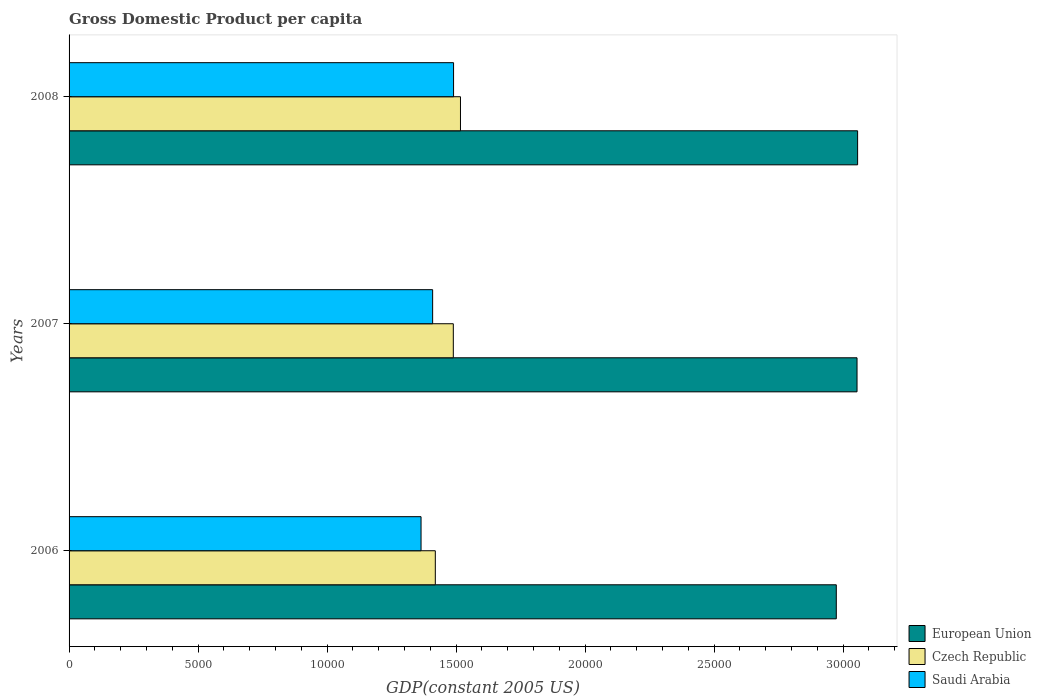How many groups of bars are there?
Your answer should be compact. 3. Are the number of bars per tick equal to the number of legend labels?
Your response must be concise. Yes. How many bars are there on the 1st tick from the bottom?
Offer a terse response. 3. What is the label of the 1st group of bars from the top?
Give a very brief answer. 2008. In how many cases, is the number of bars for a given year not equal to the number of legend labels?
Offer a very short reply. 0. What is the GDP per capita in Saudi Arabia in 2008?
Your response must be concise. 1.49e+04. Across all years, what is the maximum GDP per capita in Czech Republic?
Your response must be concise. 1.52e+04. Across all years, what is the minimum GDP per capita in European Union?
Offer a terse response. 2.97e+04. In which year was the GDP per capita in European Union maximum?
Keep it short and to the point. 2008. What is the total GDP per capita in European Union in the graph?
Provide a short and direct response. 9.08e+04. What is the difference between the GDP per capita in Czech Republic in 2006 and that in 2007?
Your response must be concise. -697.72. What is the difference between the GDP per capita in Czech Republic in 2008 and the GDP per capita in European Union in 2007?
Your answer should be very brief. -1.54e+04. What is the average GDP per capita in Czech Republic per year?
Make the answer very short. 1.48e+04. In the year 2008, what is the difference between the GDP per capita in European Union and GDP per capita in Saudi Arabia?
Provide a short and direct response. 1.57e+04. In how many years, is the GDP per capita in Saudi Arabia greater than 15000 US$?
Your answer should be compact. 0. What is the ratio of the GDP per capita in Czech Republic in 2006 to that in 2008?
Make the answer very short. 0.94. Is the difference between the GDP per capita in European Union in 2006 and 2007 greater than the difference between the GDP per capita in Saudi Arabia in 2006 and 2007?
Your answer should be compact. No. What is the difference between the highest and the second highest GDP per capita in Saudi Arabia?
Offer a very short reply. 810.83. What is the difference between the highest and the lowest GDP per capita in Saudi Arabia?
Ensure brevity in your answer.  1260.47. Is the sum of the GDP per capita in European Union in 2007 and 2008 greater than the maximum GDP per capita in Czech Republic across all years?
Your response must be concise. Yes. What does the 3rd bar from the top in 2006 represents?
Give a very brief answer. European Union. What does the 2nd bar from the bottom in 2006 represents?
Provide a succinct answer. Czech Republic. Is it the case that in every year, the sum of the GDP per capita in Czech Republic and GDP per capita in Saudi Arabia is greater than the GDP per capita in European Union?
Keep it short and to the point. No. How many years are there in the graph?
Provide a short and direct response. 3. What is the title of the graph?
Your answer should be very brief. Gross Domestic Product per capita. What is the label or title of the X-axis?
Make the answer very short. GDP(constant 2005 US). What is the GDP(constant 2005 US) of European Union in 2006?
Provide a short and direct response. 2.97e+04. What is the GDP(constant 2005 US) of Czech Republic in 2006?
Offer a very short reply. 1.42e+04. What is the GDP(constant 2005 US) of Saudi Arabia in 2006?
Make the answer very short. 1.36e+04. What is the GDP(constant 2005 US) of European Union in 2007?
Make the answer very short. 3.05e+04. What is the GDP(constant 2005 US) in Czech Republic in 2007?
Ensure brevity in your answer.  1.49e+04. What is the GDP(constant 2005 US) of Saudi Arabia in 2007?
Make the answer very short. 1.41e+04. What is the GDP(constant 2005 US) of European Union in 2008?
Give a very brief answer. 3.06e+04. What is the GDP(constant 2005 US) in Czech Republic in 2008?
Your answer should be very brief. 1.52e+04. What is the GDP(constant 2005 US) of Saudi Arabia in 2008?
Provide a succinct answer. 1.49e+04. Across all years, what is the maximum GDP(constant 2005 US) of European Union?
Ensure brevity in your answer.  3.06e+04. Across all years, what is the maximum GDP(constant 2005 US) in Czech Republic?
Offer a terse response. 1.52e+04. Across all years, what is the maximum GDP(constant 2005 US) in Saudi Arabia?
Give a very brief answer. 1.49e+04. Across all years, what is the minimum GDP(constant 2005 US) of European Union?
Provide a succinct answer. 2.97e+04. Across all years, what is the minimum GDP(constant 2005 US) of Czech Republic?
Offer a very short reply. 1.42e+04. Across all years, what is the minimum GDP(constant 2005 US) of Saudi Arabia?
Give a very brief answer. 1.36e+04. What is the total GDP(constant 2005 US) in European Union in the graph?
Provide a succinct answer. 9.08e+04. What is the total GDP(constant 2005 US) in Czech Republic in the graph?
Ensure brevity in your answer.  4.43e+04. What is the total GDP(constant 2005 US) in Saudi Arabia in the graph?
Provide a succinct answer. 4.26e+04. What is the difference between the GDP(constant 2005 US) in European Union in 2006 and that in 2007?
Keep it short and to the point. -803.51. What is the difference between the GDP(constant 2005 US) of Czech Republic in 2006 and that in 2007?
Offer a terse response. -697.72. What is the difference between the GDP(constant 2005 US) in Saudi Arabia in 2006 and that in 2007?
Give a very brief answer. -449.64. What is the difference between the GDP(constant 2005 US) in European Union in 2006 and that in 2008?
Your answer should be compact. -825.92. What is the difference between the GDP(constant 2005 US) of Czech Republic in 2006 and that in 2008?
Offer a terse response. -975.11. What is the difference between the GDP(constant 2005 US) of Saudi Arabia in 2006 and that in 2008?
Your answer should be very brief. -1260.47. What is the difference between the GDP(constant 2005 US) of European Union in 2007 and that in 2008?
Ensure brevity in your answer.  -22.42. What is the difference between the GDP(constant 2005 US) of Czech Republic in 2007 and that in 2008?
Your answer should be compact. -277.39. What is the difference between the GDP(constant 2005 US) of Saudi Arabia in 2007 and that in 2008?
Provide a short and direct response. -810.83. What is the difference between the GDP(constant 2005 US) in European Union in 2006 and the GDP(constant 2005 US) in Czech Republic in 2007?
Offer a terse response. 1.48e+04. What is the difference between the GDP(constant 2005 US) of European Union in 2006 and the GDP(constant 2005 US) of Saudi Arabia in 2007?
Your answer should be compact. 1.56e+04. What is the difference between the GDP(constant 2005 US) of Czech Republic in 2006 and the GDP(constant 2005 US) of Saudi Arabia in 2007?
Your response must be concise. 103.5. What is the difference between the GDP(constant 2005 US) in European Union in 2006 and the GDP(constant 2005 US) in Czech Republic in 2008?
Your response must be concise. 1.46e+04. What is the difference between the GDP(constant 2005 US) in European Union in 2006 and the GDP(constant 2005 US) in Saudi Arabia in 2008?
Keep it short and to the point. 1.48e+04. What is the difference between the GDP(constant 2005 US) of Czech Republic in 2006 and the GDP(constant 2005 US) of Saudi Arabia in 2008?
Make the answer very short. -707.33. What is the difference between the GDP(constant 2005 US) in European Union in 2007 and the GDP(constant 2005 US) in Czech Republic in 2008?
Provide a short and direct response. 1.54e+04. What is the difference between the GDP(constant 2005 US) of European Union in 2007 and the GDP(constant 2005 US) of Saudi Arabia in 2008?
Make the answer very short. 1.56e+04. What is the difference between the GDP(constant 2005 US) of Czech Republic in 2007 and the GDP(constant 2005 US) of Saudi Arabia in 2008?
Your answer should be compact. -9.6. What is the average GDP(constant 2005 US) of European Union per year?
Keep it short and to the point. 3.03e+04. What is the average GDP(constant 2005 US) in Czech Republic per year?
Keep it short and to the point. 1.48e+04. What is the average GDP(constant 2005 US) of Saudi Arabia per year?
Give a very brief answer. 1.42e+04. In the year 2006, what is the difference between the GDP(constant 2005 US) in European Union and GDP(constant 2005 US) in Czech Republic?
Keep it short and to the point. 1.55e+04. In the year 2006, what is the difference between the GDP(constant 2005 US) of European Union and GDP(constant 2005 US) of Saudi Arabia?
Make the answer very short. 1.61e+04. In the year 2006, what is the difference between the GDP(constant 2005 US) of Czech Republic and GDP(constant 2005 US) of Saudi Arabia?
Make the answer very short. 553.14. In the year 2007, what is the difference between the GDP(constant 2005 US) of European Union and GDP(constant 2005 US) of Czech Republic?
Keep it short and to the point. 1.56e+04. In the year 2007, what is the difference between the GDP(constant 2005 US) of European Union and GDP(constant 2005 US) of Saudi Arabia?
Keep it short and to the point. 1.64e+04. In the year 2007, what is the difference between the GDP(constant 2005 US) of Czech Republic and GDP(constant 2005 US) of Saudi Arabia?
Your response must be concise. 801.22. In the year 2008, what is the difference between the GDP(constant 2005 US) of European Union and GDP(constant 2005 US) of Czech Republic?
Provide a short and direct response. 1.54e+04. In the year 2008, what is the difference between the GDP(constant 2005 US) of European Union and GDP(constant 2005 US) of Saudi Arabia?
Make the answer very short. 1.57e+04. In the year 2008, what is the difference between the GDP(constant 2005 US) of Czech Republic and GDP(constant 2005 US) of Saudi Arabia?
Your response must be concise. 267.79. What is the ratio of the GDP(constant 2005 US) in European Union in 2006 to that in 2007?
Your answer should be compact. 0.97. What is the ratio of the GDP(constant 2005 US) in Czech Republic in 2006 to that in 2007?
Provide a succinct answer. 0.95. What is the ratio of the GDP(constant 2005 US) in Saudi Arabia in 2006 to that in 2007?
Provide a succinct answer. 0.97. What is the ratio of the GDP(constant 2005 US) of Czech Republic in 2006 to that in 2008?
Offer a terse response. 0.94. What is the ratio of the GDP(constant 2005 US) of Saudi Arabia in 2006 to that in 2008?
Ensure brevity in your answer.  0.92. What is the ratio of the GDP(constant 2005 US) of European Union in 2007 to that in 2008?
Offer a terse response. 1. What is the ratio of the GDP(constant 2005 US) of Czech Republic in 2007 to that in 2008?
Keep it short and to the point. 0.98. What is the ratio of the GDP(constant 2005 US) of Saudi Arabia in 2007 to that in 2008?
Offer a very short reply. 0.95. What is the difference between the highest and the second highest GDP(constant 2005 US) of European Union?
Offer a very short reply. 22.42. What is the difference between the highest and the second highest GDP(constant 2005 US) of Czech Republic?
Give a very brief answer. 277.39. What is the difference between the highest and the second highest GDP(constant 2005 US) of Saudi Arabia?
Give a very brief answer. 810.83. What is the difference between the highest and the lowest GDP(constant 2005 US) in European Union?
Your answer should be compact. 825.92. What is the difference between the highest and the lowest GDP(constant 2005 US) of Czech Republic?
Make the answer very short. 975.11. What is the difference between the highest and the lowest GDP(constant 2005 US) in Saudi Arabia?
Your response must be concise. 1260.47. 